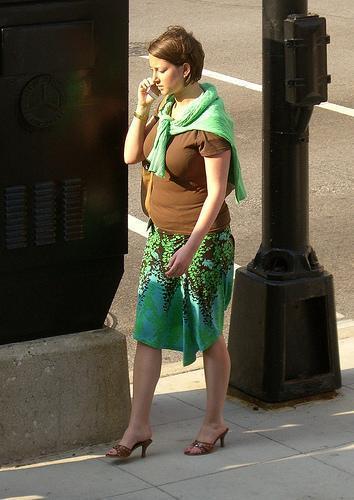How many legs does the woman have?
Give a very brief answer. 2. 